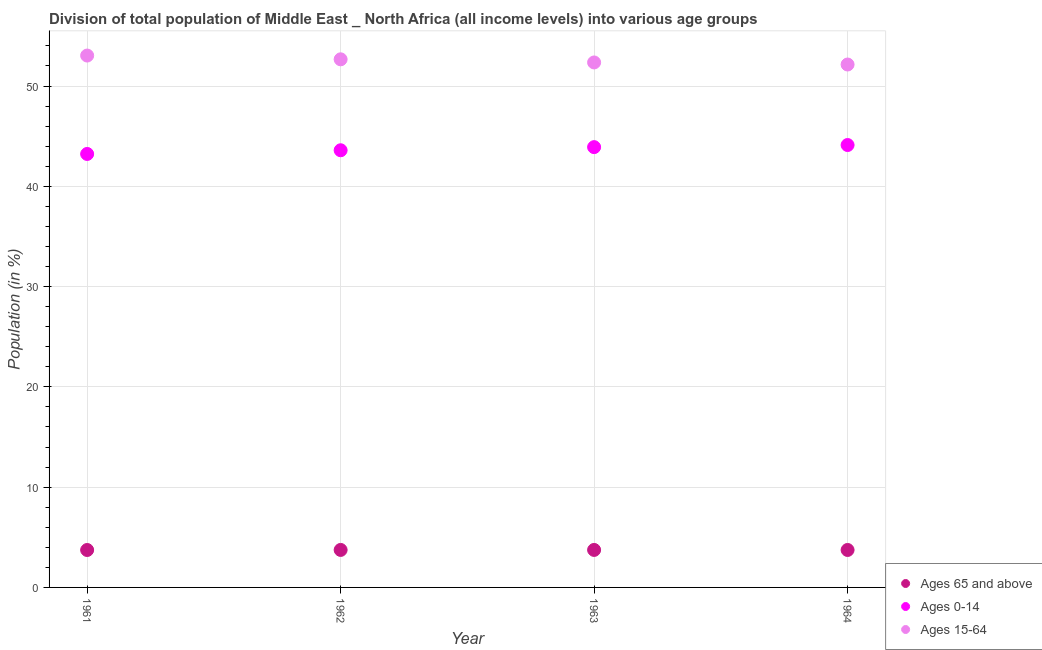Is the number of dotlines equal to the number of legend labels?
Your answer should be very brief. Yes. What is the percentage of population within the age-group 15-64 in 1963?
Keep it short and to the point. 52.35. Across all years, what is the maximum percentage of population within the age-group 15-64?
Offer a terse response. 53.04. Across all years, what is the minimum percentage of population within the age-group 15-64?
Provide a short and direct response. 52.15. What is the total percentage of population within the age-group of 65 and above in the graph?
Offer a terse response. 14.95. What is the difference between the percentage of population within the age-group of 65 and above in 1962 and that in 1964?
Your answer should be very brief. 0. What is the difference between the percentage of population within the age-group 0-14 in 1962 and the percentage of population within the age-group of 65 and above in 1964?
Provide a short and direct response. 39.86. What is the average percentage of population within the age-group of 65 and above per year?
Your answer should be very brief. 3.74. In the year 1962, what is the difference between the percentage of population within the age-group of 65 and above and percentage of population within the age-group 0-14?
Ensure brevity in your answer.  -39.86. In how many years, is the percentage of population within the age-group 0-14 greater than 34 %?
Offer a very short reply. 4. What is the ratio of the percentage of population within the age-group of 65 and above in 1962 to that in 1964?
Your answer should be very brief. 1. Is the percentage of population within the age-group of 65 and above in 1961 less than that in 1963?
Ensure brevity in your answer.  Yes. What is the difference between the highest and the second highest percentage of population within the age-group of 65 and above?
Offer a terse response. 0. What is the difference between the highest and the lowest percentage of population within the age-group 15-64?
Make the answer very short. 0.89. In how many years, is the percentage of population within the age-group of 65 and above greater than the average percentage of population within the age-group of 65 and above taken over all years?
Your response must be concise. 2. Is it the case that in every year, the sum of the percentage of population within the age-group of 65 and above and percentage of population within the age-group 0-14 is greater than the percentage of population within the age-group 15-64?
Make the answer very short. No. Does the percentage of population within the age-group 15-64 monotonically increase over the years?
Provide a succinct answer. No. Is the percentage of population within the age-group 15-64 strictly less than the percentage of population within the age-group of 65 and above over the years?
Make the answer very short. No. How many dotlines are there?
Provide a succinct answer. 3. How many years are there in the graph?
Provide a short and direct response. 4. What is the difference between two consecutive major ticks on the Y-axis?
Offer a terse response. 10. Are the values on the major ticks of Y-axis written in scientific E-notation?
Offer a very short reply. No. Where does the legend appear in the graph?
Keep it short and to the point. Bottom right. How many legend labels are there?
Ensure brevity in your answer.  3. How are the legend labels stacked?
Your response must be concise. Vertical. What is the title of the graph?
Your answer should be very brief. Division of total population of Middle East _ North Africa (all income levels) into various age groups
. What is the label or title of the X-axis?
Make the answer very short. Year. What is the label or title of the Y-axis?
Give a very brief answer. Population (in %). What is the Population (in %) in Ages 65 and above in 1961?
Your answer should be very brief. 3.73. What is the Population (in %) in Ages 0-14 in 1961?
Provide a succinct answer. 43.23. What is the Population (in %) in Ages 15-64 in 1961?
Your answer should be very brief. 53.04. What is the Population (in %) of Ages 65 and above in 1962?
Your answer should be compact. 3.74. What is the Population (in %) in Ages 0-14 in 1962?
Provide a short and direct response. 43.6. What is the Population (in %) in Ages 15-64 in 1962?
Your response must be concise. 52.67. What is the Population (in %) in Ages 65 and above in 1963?
Ensure brevity in your answer.  3.74. What is the Population (in %) of Ages 0-14 in 1963?
Ensure brevity in your answer.  43.91. What is the Population (in %) in Ages 15-64 in 1963?
Offer a very short reply. 52.35. What is the Population (in %) in Ages 65 and above in 1964?
Offer a terse response. 3.74. What is the Population (in %) in Ages 0-14 in 1964?
Ensure brevity in your answer.  44.12. What is the Population (in %) of Ages 15-64 in 1964?
Offer a very short reply. 52.15. Across all years, what is the maximum Population (in %) in Ages 65 and above?
Make the answer very short. 3.74. Across all years, what is the maximum Population (in %) in Ages 0-14?
Provide a succinct answer. 44.12. Across all years, what is the maximum Population (in %) of Ages 15-64?
Make the answer very short. 53.04. Across all years, what is the minimum Population (in %) of Ages 65 and above?
Your answer should be compact. 3.73. Across all years, what is the minimum Population (in %) of Ages 0-14?
Keep it short and to the point. 43.23. Across all years, what is the minimum Population (in %) in Ages 15-64?
Provide a succinct answer. 52.15. What is the total Population (in %) of Ages 65 and above in the graph?
Provide a succinct answer. 14.95. What is the total Population (in %) of Ages 0-14 in the graph?
Ensure brevity in your answer.  174.85. What is the total Population (in %) in Ages 15-64 in the graph?
Keep it short and to the point. 210.21. What is the difference between the Population (in %) in Ages 65 and above in 1961 and that in 1962?
Offer a very short reply. -0.01. What is the difference between the Population (in %) in Ages 0-14 in 1961 and that in 1962?
Provide a short and direct response. -0.37. What is the difference between the Population (in %) of Ages 15-64 in 1961 and that in 1962?
Offer a terse response. 0.38. What is the difference between the Population (in %) of Ages 65 and above in 1961 and that in 1963?
Your response must be concise. -0.01. What is the difference between the Population (in %) in Ages 0-14 in 1961 and that in 1963?
Keep it short and to the point. -0.68. What is the difference between the Population (in %) of Ages 15-64 in 1961 and that in 1963?
Ensure brevity in your answer.  0.69. What is the difference between the Population (in %) in Ages 65 and above in 1961 and that in 1964?
Provide a short and direct response. -0. What is the difference between the Population (in %) of Ages 0-14 in 1961 and that in 1964?
Offer a very short reply. -0.89. What is the difference between the Population (in %) of Ages 15-64 in 1961 and that in 1964?
Offer a very short reply. 0.89. What is the difference between the Population (in %) of Ages 65 and above in 1962 and that in 1963?
Give a very brief answer. -0. What is the difference between the Population (in %) in Ages 0-14 in 1962 and that in 1963?
Offer a terse response. -0.31. What is the difference between the Population (in %) of Ages 15-64 in 1962 and that in 1963?
Keep it short and to the point. 0.31. What is the difference between the Population (in %) in Ages 65 and above in 1962 and that in 1964?
Offer a very short reply. 0. What is the difference between the Population (in %) in Ages 0-14 in 1962 and that in 1964?
Provide a short and direct response. -0.52. What is the difference between the Population (in %) in Ages 15-64 in 1962 and that in 1964?
Provide a short and direct response. 0.52. What is the difference between the Population (in %) of Ages 65 and above in 1963 and that in 1964?
Offer a very short reply. 0. What is the difference between the Population (in %) of Ages 0-14 in 1963 and that in 1964?
Make the answer very short. -0.21. What is the difference between the Population (in %) in Ages 15-64 in 1963 and that in 1964?
Provide a short and direct response. 0.21. What is the difference between the Population (in %) in Ages 65 and above in 1961 and the Population (in %) in Ages 0-14 in 1962?
Keep it short and to the point. -39.86. What is the difference between the Population (in %) in Ages 65 and above in 1961 and the Population (in %) in Ages 15-64 in 1962?
Your response must be concise. -48.93. What is the difference between the Population (in %) in Ages 0-14 in 1961 and the Population (in %) in Ages 15-64 in 1962?
Provide a succinct answer. -9.44. What is the difference between the Population (in %) of Ages 65 and above in 1961 and the Population (in %) of Ages 0-14 in 1963?
Give a very brief answer. -40.18. What is the difference between the Population (in %) of Ages 65 and above in 1961 and the Population (in %) of Ages 15-64 in 1963?
Your response must be concise. -48.62. What is the difference between the Population (in %) in Ages 0-14 in 1961 and the Population (in %) in Ages 15-64 in 1963?
Keep it short and to the point. -9.13. What is the difference between the Population (in %) in Ages 65 and above in 1961 and the Population (in %) in Ages 0-14 in 1964?
Offer a terse response. -40.39. What is the difference between the Population (in %) of Ages 65 and above in 1961 and the Population (in %) of Ages 15-64 in 1964?
Ensure brevity in your answer.  -48.41. What is the difference between the Population (in %) in Ages 0-14 in 1961 and the Population (in %) in Ages 15-64 in 1964?
Your response must be concise. -8.92. What is the difference between the Population (in %) in Ages 65 and above in 1962 and the Population (in %) in Ages 0-14 in 1963?
Your answer should be compact. -40.17. What is the difference between the Population (in %) in Ages 65 and above in 1962 and the Population (in %) in Ages 15-64 in 1963?
Provide a succinct answer. -48.61. What is the difference between the Population (in %) of Ages 0-14 in 1962 and the Population (in %) of Ages 15-64 in 1963?
Keep it short and to the point. -8.76. What is the difference between the Population (in %) of Ages 65 and above in 1962 and the Population (in %) of Ages 0-14 in 1964?
Provide a succinct answer. -40.38. What is the difference between the Population (in %) of Ages 65 and above in 1962 and the Population (in %) of Ages 15-64 in 1964?
Provide a succinct answer. -48.41. What is the difference between the Population (in %) of Ages 0-14 in 1962 and the Population (in %) of Ages 15-64 in 1964?
Provide a short and direct response. -8.55. What is the difference between the Population (in %) in Ages 65 and above in 1963 and the Population (in %) in Ages 0-14 in 1964?
Ensure brevity in your answer.  -40.38. What is the difference between the Population (in %) in Ages 65 and above in 1963 and the Population (in %) in Ages 15-64 in 1964?
Give a very brief answer. -48.41. What is the difference between the Population (in %) of Ages 0-14 in 1963 and the Population (in %) of Ages 15-64 in 1964?
Offer a terse response. -8.24. What is the average Population (in %) in Ages 65 and above per year?
Offer a terse response. 3.74. What is the average Population (in %) in Ages 0-14 per year?
Keep it short and to the point. 43.71. What is the average Population (in %) in Ages 15-64 per year?
Your response must be concise. 52.55. In the year 1961, what is the difference between the Population (in %) in Ages 65 and above and Population (in %) in Ages 0-14?
Your answer should be very brief. -39.49. In the year 1961, what is the difference between the Population (in %) in Ages 65 and above and Population (in %) in Ages 15-64?
Your answer should be compact. -49.31. In the year 1961, what is the difference between the Population (in %) of Ages 0-14 and Population (in %) of Ages 15-64?
Your answer should be very brief. -9.81. In the year 1962, what is the difference between the Population (in %) in Ages 65 and above and Population (in %) in Ages 0-14?
Keep it short and to the point. -39.86. In the year 1962, what is the difference between the Population (in %) of Ages 65 and above and Population (in %) of Ages 15-64?
Make the answer very short. -48.93. In the year 1962, what is the difference between the Population (in %) of Ages 0-14 and Population (in %) of Ages 15-64?
Ensure brevity in your answer.  -9.07. In the year 1963, what is the difference between the Population (in %) in Ages 65 and above and Population (in %) in Ages 0-14?
Make the answer very short. -40.17. In the year 1963, what is the difference between the Population (in %) of Ages 65 and above and Population (in %) of Ages 15-64?
Provide a short and direct response. -48.61. In the year 1963, what is the difference between the Population (in %) in Ages 0-14 and Population (in %) in Ages 15-64?
Keep it short and to the point. -8.45. In the year 1964, what is the difference between the Population (in %) in Ages 65 and above and Population (in %) in Ages 0-14?
Provide a short and direct response. -40.38. In the year 1964, what is the difference between the Population (in %) in Ages 65 and above and Population (in %) in Ages 15-64?
Keep it short and to the point. -48.41. In the year 1964, what is the difference between the Population (in %) in Ages 0-14 and Population (in %) in Ages 15-64?
Keep it short and to the point. -8.03. What is the ratio of the Population (in %) of Ages 0-14 in 1961 to that in 1962?
Your response must be concise. 0.99. What is the ratio of the Population (in %) in Ages 15-64 in 1961 to that in 1962?
Make the answer very short. 1.01. What is the ratio of the Population (in %) of Ages 65 and above in 1961 to that in 1963?
Ensure brevity in your answer.  1. What is the ratio of the Population (in %) in Ages 0-14 in 1961 to that in 1963?
Make the answer very short. 0.98. What is the ratio of the Population (in %) of Ages 15-64 in 1961 to that in 1963?
Ensure brevity in your answer.  1.01. What is the ratio of the Population (in %) in Ages 0-14 in 1961 to that in 1964?
Offer a terse response. 0.98. What is the ratio of the Population (in %) in Ages 15-64 in 1961 to that in 1964?
Provide a short and direct response. 1.02. What is the ratio of the Population (in %) of Ages 0-14 in 1962 to that in 1963?
Keep it short and to the point. 0.99. What is the ratio of the Population (in %) in Ages 0-14 in 1962 to that in 1964?
Provide a succinct answer. 0.99. What is the ratio of the Population (in %) of Ages 15-64 in 1962 to that in 1964?
Keep it short and to the point. 1.01. What is the ratio of the Population (in %) in Ages 65 and above in 1963 to that in 1964?
Offer a very short reply. 1. What is the ratio of the Population (in %) in Ages 0-14 in 1963 to that in 1964?
Ensure brevity in your answer.  1. What is the ratio of the Population (in %) in Ages 15-64 in 1963 to that in 1964?
Keep it short and to the point. 1. What is the difference between the highest and the second highest Population (in %) in Ages 0-14?
Provide a short and direct response. 0.21. What is the difference between the highest and the second highest Population (in %) in Ages 15-64?
Keep it short and to the point. 0.38. What is the difference between the highest and the lowest Population (in %) of Ages 65 and above?
Your response must be concise. 0.01. What is the difference between the highest and the lowest Population (in %) in Ages 0-14?
Keep it short and to the point. 0.89. What is the difference between the highest and the lowest Population (in %) of Ages 15-64?
Offer a terse response. 0.89. 